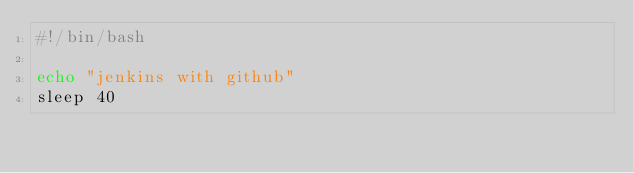Convert code to text. <code><loc_0><loc_0><loc_500><loc_500><_Bash_>#!/bin/bash

echo "jenkins with github"
sleep 40
</code> 